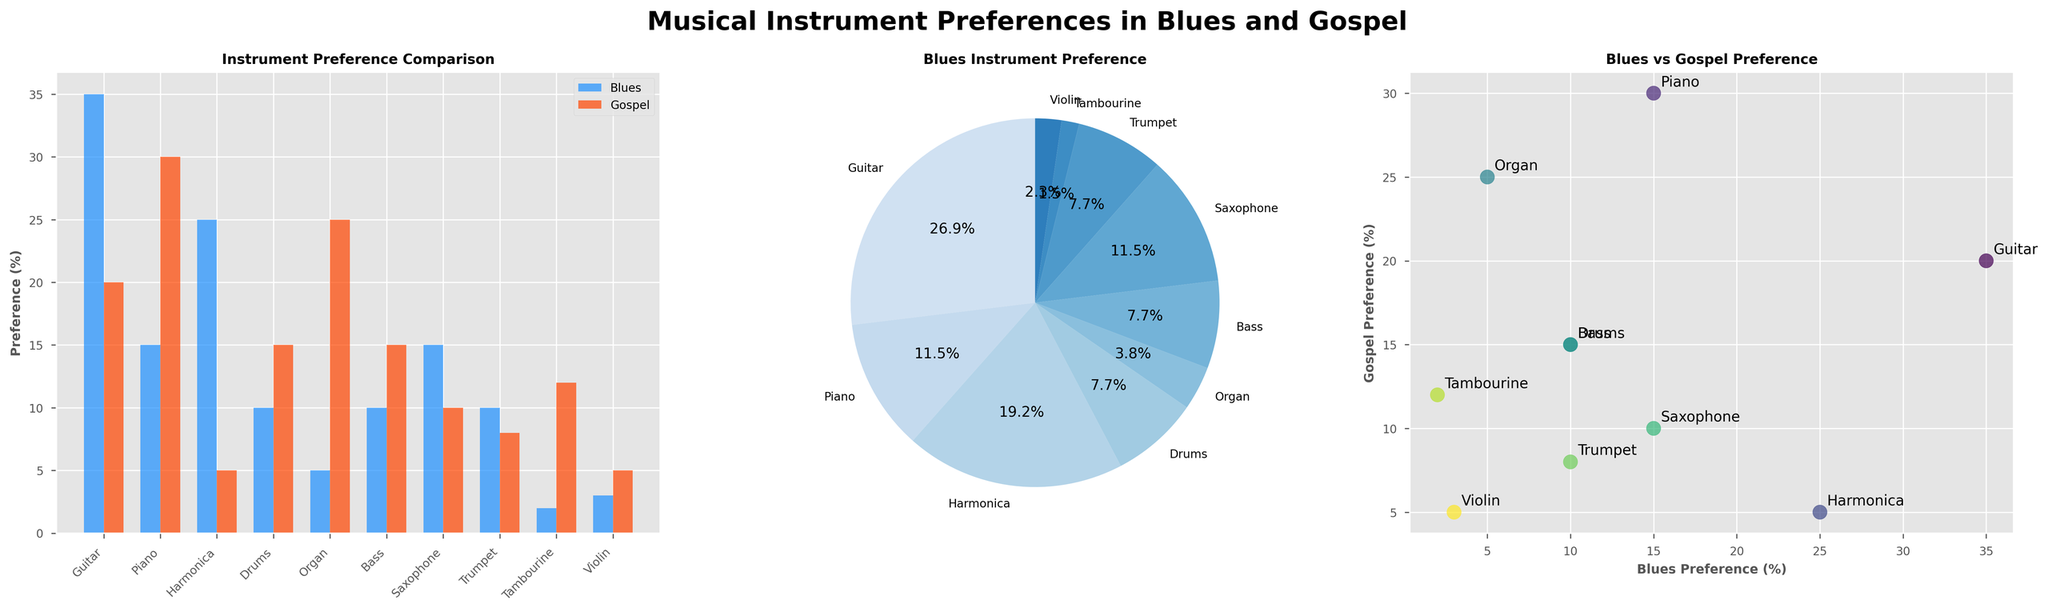How many instruments prefered by Blues musicians are above 20%? In the bar plot, observe the blue bars to identify values greater than 20%. The bars corresponding to Guitar (35%) and Harmonica (25%) exceed this threshold, so there are 2 instruments.
Answer: 2 Which instrument has the highest preference among Gospel musicians? Check the highest orange bar in the bar plot and the corresponding pie chart slice for Gospel preferences. The Piano (30%) stands out as the highest preference among Gospel musicians.
Answer: Piano What is the average preference of the Guitar and Piano in Blues? From the bar plot, find the percentages for Guitar (35%) and Piano (15%). The sum of these values is 50. The average is calculated as 50/2 = 25%.
Answer: 25% Compare the preference of Harmonica in Blues and Gospel. Which one is higher? Look at Harmonica's bar in both the blue and orange colors in the bar plot. For Blues, it's 25%, and for Gospel, it's 5%. Thus, Harmonica is more preferred in Blues.
Answer: Blues What is the sum of the preferences for Drums and Organ in Gospel music? In the bar plot, locate the orange bars for Drums and Organ (15% and 25%, respectively). Adding these gives 15 + 25 = 40%.
Answer: 40% How does the preference for the Bass differ between the Blues and Gospel musicians? Identify the Bass preference values from the bar plot, which are 10% for both Blues and Gospel. The difference is 0 because they are the same.
Answer: 0 Which instrument has the closest preference percentage between Blues and Gospel? Compare the bars for each instrument in the bar plot. The Bass shows 10% in both preferences, indicating it has the closest percentages.
Answer: Bass What are the first and third most preferred instruments among Gospel musicians? Refer to the orange bars in the bar plot and Gospel pie chart. The highest preference is Piano (30%), followed by Organ (25%), hence Piano and Organ are the first and third most preferred instruments, in that order.
Answer: Piano, Organ Which instrument appears at the top-left corner in the scatter plot, indicating low preference values for both Blues and Gospel? Find the instrument at the top-left corner of the scatter plot. The Tambourine (2%, 12%) is located here, representing low values for both genres.
Answer: Tambourine What is the difference in percentage for Saxophone preference between Blues and Gospel? From the bar plot, locate the Saxophone preferences: Blues at 15% and Gospel at 10%. The difference is calculated as 15 - 10 = 5%.
Answer: 5 